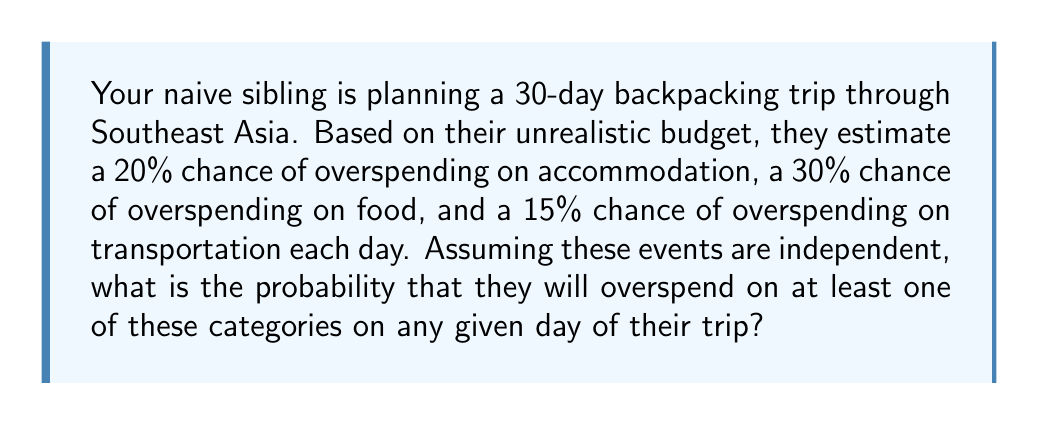Help me with this question. To solve this problem, we need to use the concept of probability for independent events.

Step 1: Calculate the probability of not overspending on each category.
Accommodation: $P(\text{not overspending}) = 1 - 0.20 = 0.80$
Food: $P(\text{not overspending}) = 1 - 0.30 = 0.70$
Transportation: $P(\text{not overspending}) = 1 - 0.15 = 0.85$

Step 2: Calculate the probability of not overspending on any category.
Since the events are independent, we multiply the probabilities:
$P(\text{not overspending on any}) = 0.80 \times 0.70 \times 0.85 = 0.476$

Step 3: Calculate the probability of overspending on at least one category.
This is the complement of not overspending on any category:
$P(\text{overspending on at least one}) = 1 - P(\text{not overspending on any})$
$P(\text{overspending on at least one}) = 1 - 0.476 = 0.524$

Therefore, the probability of overspending on at least one category on any given day is 0.524 or 52.4%.
Answer: 0.524 